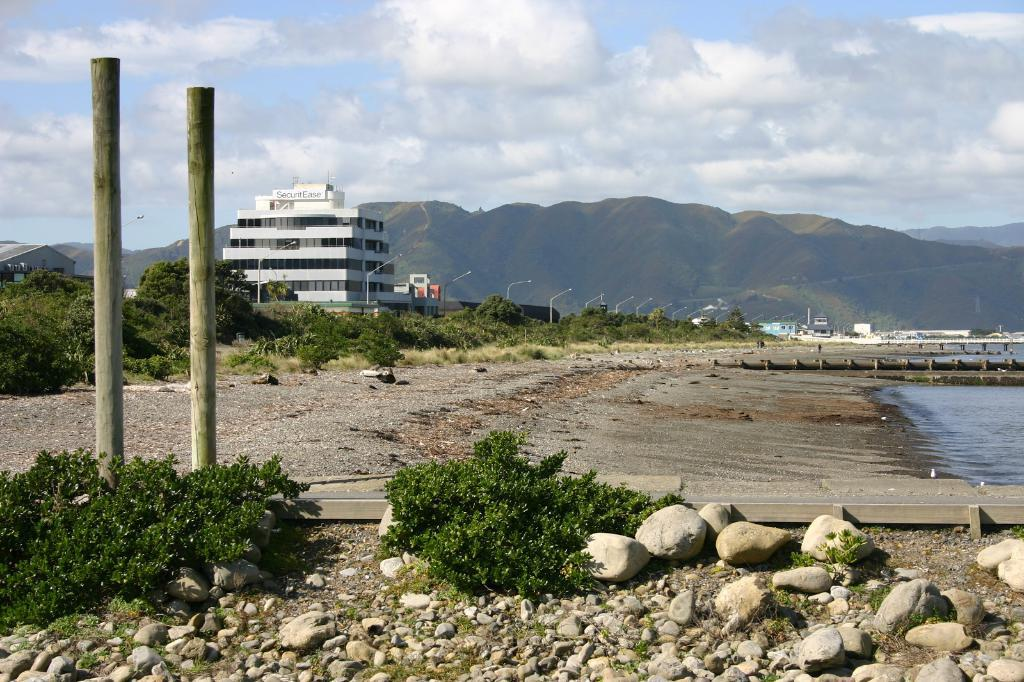What can be seen in the sky in the image? The sky is visible in the image. What type of structure is present in the image? There is a building in the image. What object is located on the right side of the image? There is a pole on the right side of the image. What natural feature is present in the image? A lake is present in the image. What type of ground surface is visible in the image? Stones are visible in the image. What type of wound can be seen on the jar in the image? There is no jar or wound present in the image. What color is the copper in the image? There is no copper present in the image. 